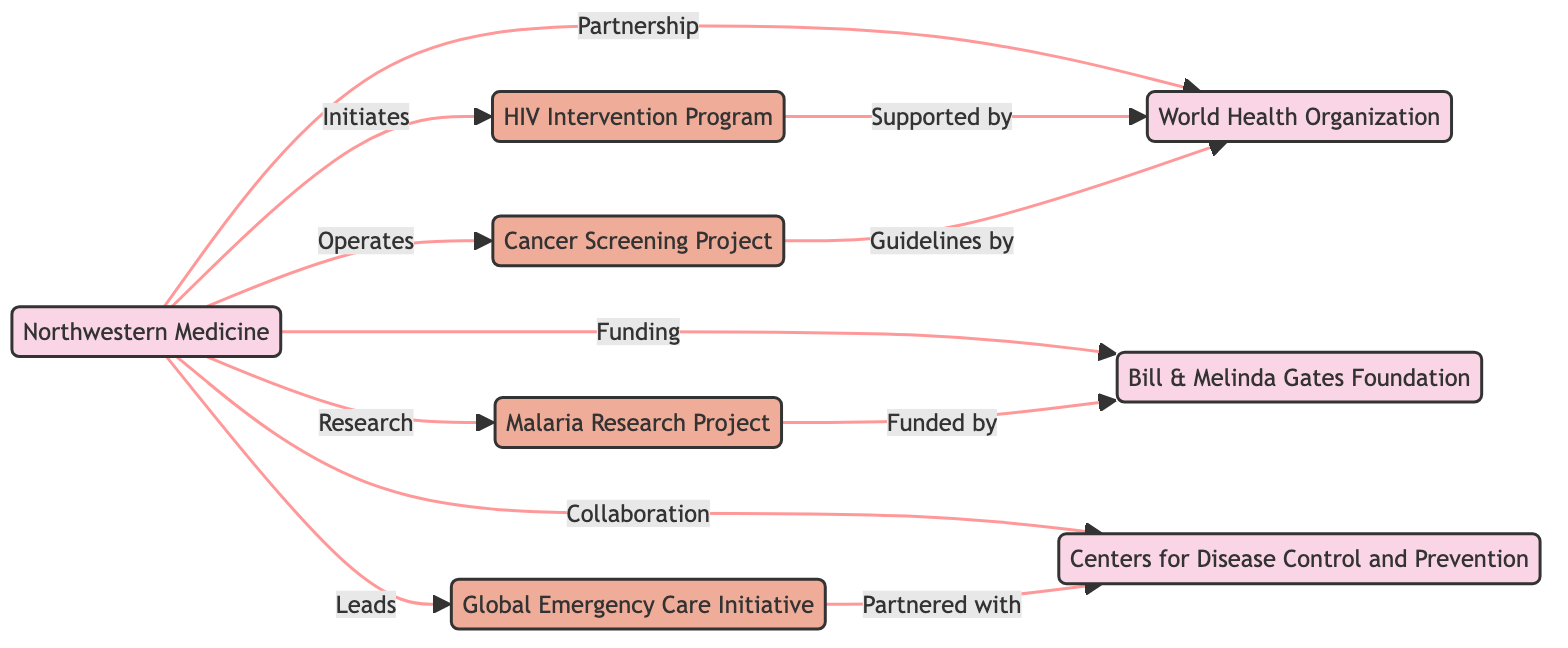What is the total number of nodes in the diagram? The diagram contains a list of nodes, which are Northwestern Medicine, World Health Organization, Bill & Melinda Gates Foundation, Centers for Disease Control and Prevention, HIV Intervention Program, Global Emergency Care Initiative, Malaria Research Project, and Cancer Screening Project. Counting these, we find there are 8 nodes in total.
Answer: 8 Who does Northwestern Medicine collaborate with? In the diagram, there is a direct edge labeled 'Collaboration' leading from Northwestern Medicine to the Centers for Disease Control and Prevention, indicating a collaboration between these two entities.
Answer: Centers for Disease Control and Prevention Which project does Northwestern Medicine initiate? There’s an edge labeled 'Initiates' from Northwestern Medicine leading to the HIV Intervention Program, signifying that Northwestern Medicine is the initiator of this project.
Answer: HIV Intervention Program How many projects are funded by the Bill & Melinda Gates Foundation? Upon examining the diagram, it is evident there are two edges showing direct funding relations: one from the Malaria Research Project to the Gates Foundation and another stating that this project is funded by it. Therefore, only one project is indicated as funded by the Gates Foundation.
Answer: 1 What relationship exists between the Global Emergency Care Initiative and the Centers for Disease Control and Prevention? The edge connecting the Global Emergency Care Initiative and the Centers for Disease Control and Prevention is labeled 'Partnered with', indicating a partnership relationship between these organizations concerning this initiative.
Answer: Partnered with Which organization provides guidelines for the Cancer Screening Project? In the diagram, there is a connection from the Cancer Screening Project to the World Health Organization, marked with 'Guidelines by', suggesting that the World Health Organization is the organization responsible for providing guidelines related to this project.
Answer: World Health Organization What type of funding does Northwestern Medicine receive from the Gates Foundation? The edge connecting Northwestern Medicine to the Gates Foundation is labeled 'Funding', indicating that Northwestern Medicine receives financial support from the Gates Foundation for projects or initiatives.
Answer: Funding What is the primary project led by Northwestern Medicine? The diagram indicates that Northwestern Medicine leads the Global Emergency Care Initiative, as this is denoted by the label 'Leads' pointing from Northwestern Medicine to this specific project.
Answer: Global Emergency Care Initiative 